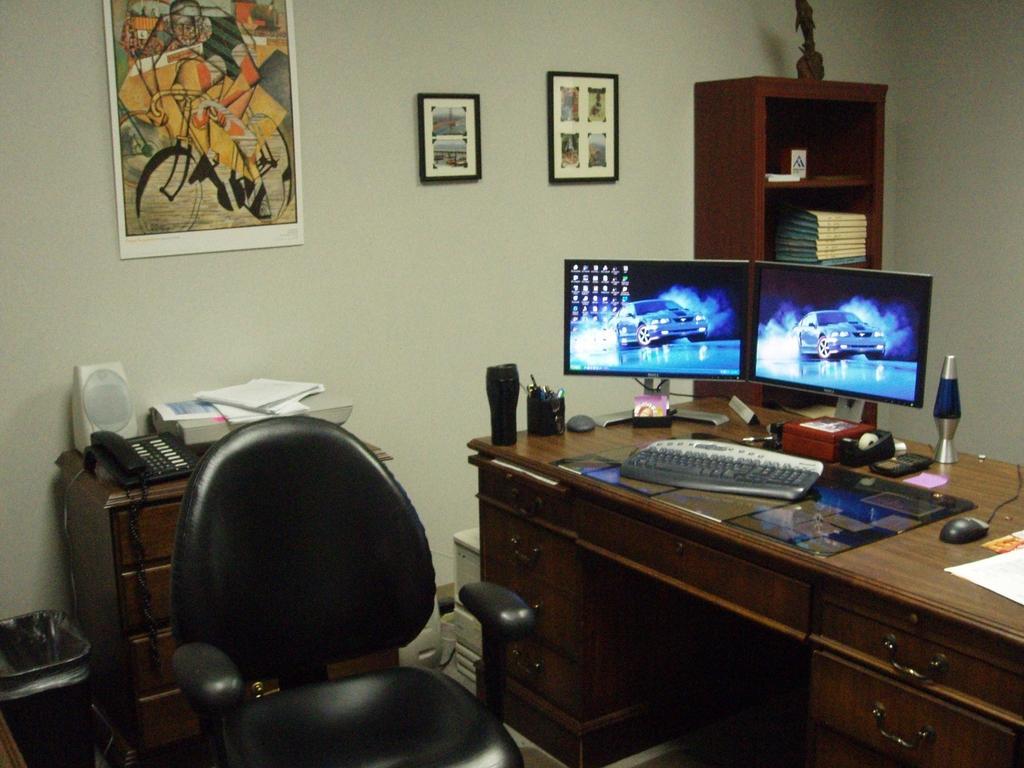Can you describe this image briefly? In this image we can see a table, on that there are two monitors, a keyboard, a mouse, a bottle, and some other objects, there are photo frames on the wall, there are files, a sculpture on the closet, there are books, a telephone, and an object on the cupboard, there is a chair, a dustbin. 